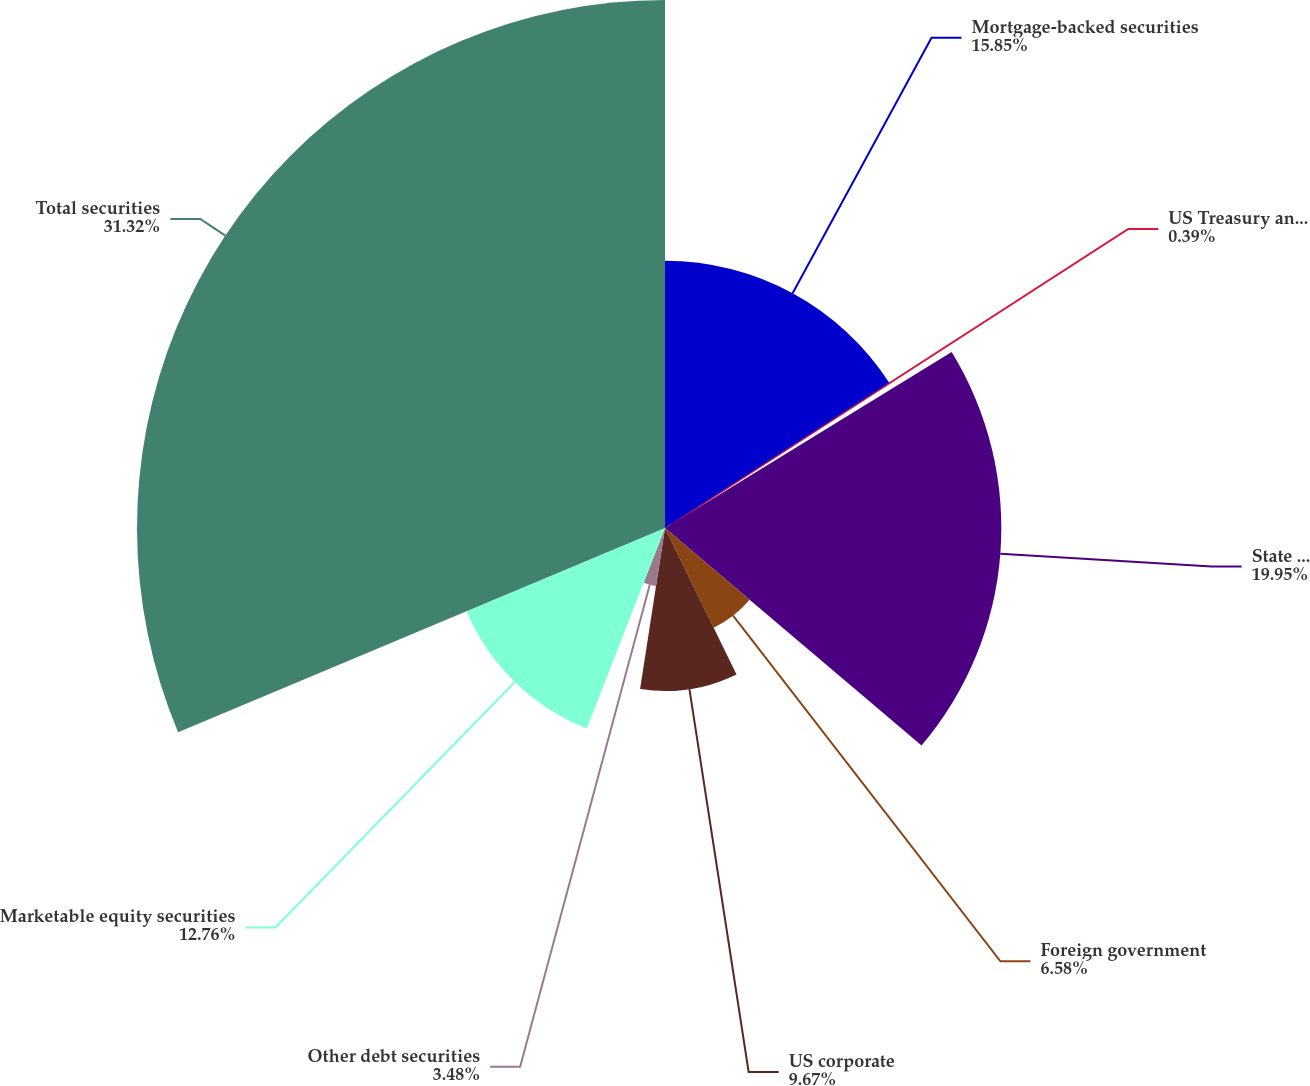Convert chart to OTSL. <chart><loc_0><loc_0><loc_500><loc_500><pie_chart><fcel>Mortgage-backed securities<fcel>US Treasury and federal<fcel>State and municipal<fcel>Foreign government<fcel>US corporate<fcel>Other debt securities<fcel>Marketable equity securities<fcel>Total securities<nl><fcel>15.85%<fcel>0.39%<fcel>19.95%<fcel>6.58%<fcel>9.67%<fcel>3.48%<fcel>12.76%<fcel>31.32%<nl></chart> 